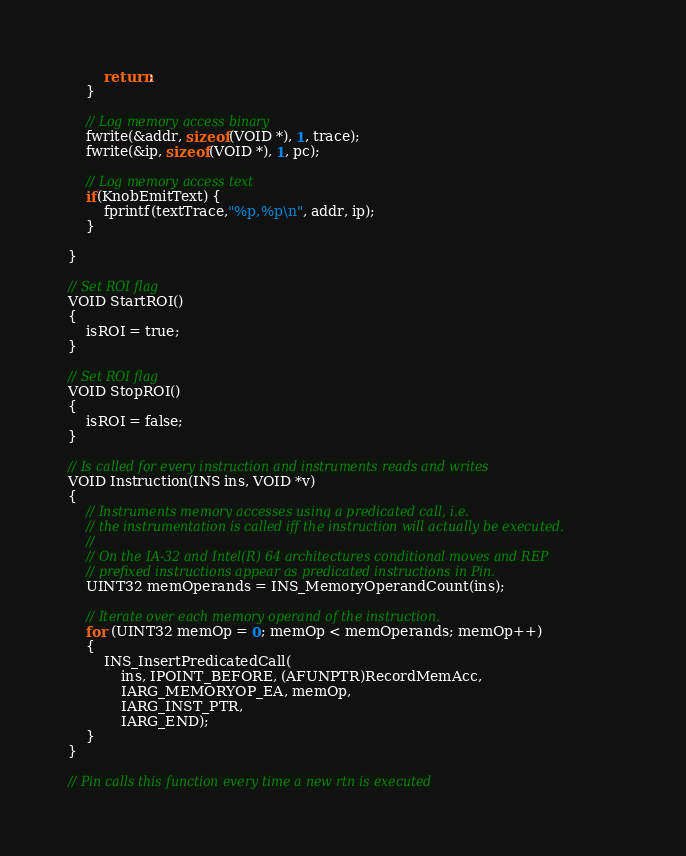<code> <loc_0><loc_0><loc_500><loc_500><_C++_>        return;
    }

    // Log memory access binary
    fwrite(&addr, sizeof(VOID *), 1, trace);
    fwrite(&ip, sizeof(VOID *), 1, pc);

    // Log memory access text
    if(KnobEmitText) {
        fprintf(textTrace,"%p,%p\n", addr, ip);
    }

}

// Set ROI flag
VOID StartROI()
{
    isROI = true;
}

// Set ROI flag
VOID StopROI()
{
    isROI = false;
}

// Is called for every instruction and instruments reads and writes
VOID Instruction(INS ins, VOID *v)
{
    // Instruments memory accesses using a predicated call, i.e.
    // the instrumentation is called iff the instruction will actually be executed.
    //
    // On the IA-32 and Intel(R) 64 architectures conditional moves and REP 
    // prefixed instructions appear as predicated instructions in Pin.
    UINT32 memOperands = INS_MemoryOperandCount(ins);

    // Iterate over each memory operand of the instruction.
    for (UINT32 memOp = 0; memOp < memOperands; memOp++)
    {
        INS_InsertPredicatedCall(
            ins, IPOINT_BEFORE, (AFUNPTR)RecordMemAcc,
            IARG_MEMORYOP_EA, memOp,
            IARG_INST_PTR,
            IARG_END);
    }
}

// Pin calls this function every time a new rtn is executed</code> 